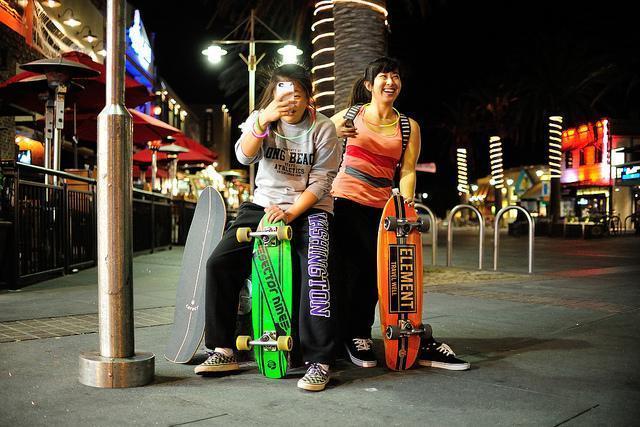How many people are there?
Give a very brief answer. 2. How many skateboards are in the picture?
Give a very brief answer. 3. 